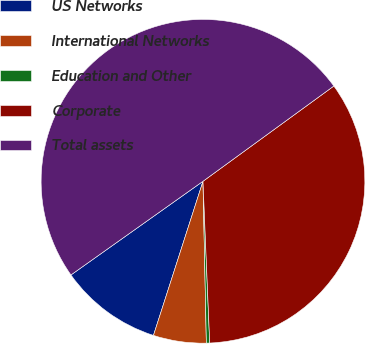Convert chart. <chart><loc_0><loc_0><loc_500><loc_500><pie_chart><fcel>US Networks<fcel>International Networks<fcel>Education and Other<fcel>Corporate<fcel>Total assets<nl><fcel>10.23%<fcel>5.28%<fcel>0.33%<fcel>34.35%<fcel>49.8%<nl></chart> 